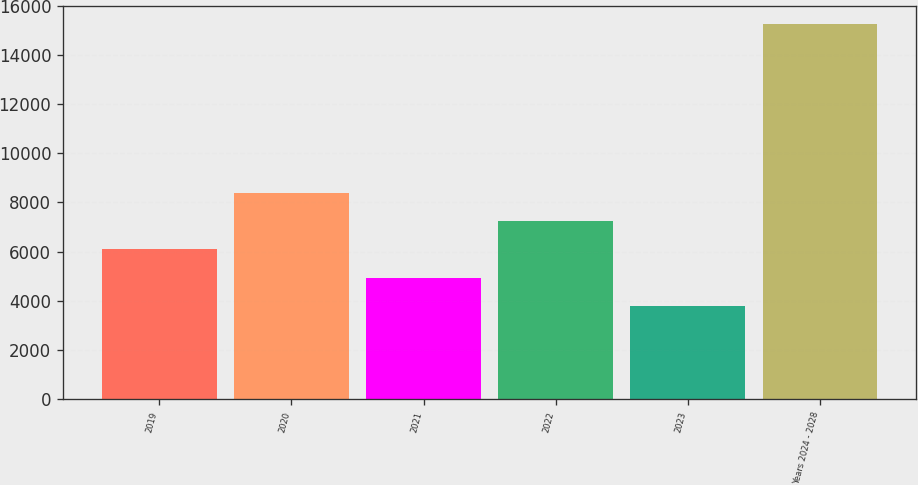<chart> <loc_0><loc_0><loc_500><loc_500><bar_chart><fcel>2019<fcel>2020<fcel>2021<fcel>2022<fcel>2023<fcel>Years 2024 - 2028<nl><fcel>6084.2<fcel>8373.4<fcel>4939.6<fcel>7228.8<fcel>3795<fcel>15241<nl></chart> 